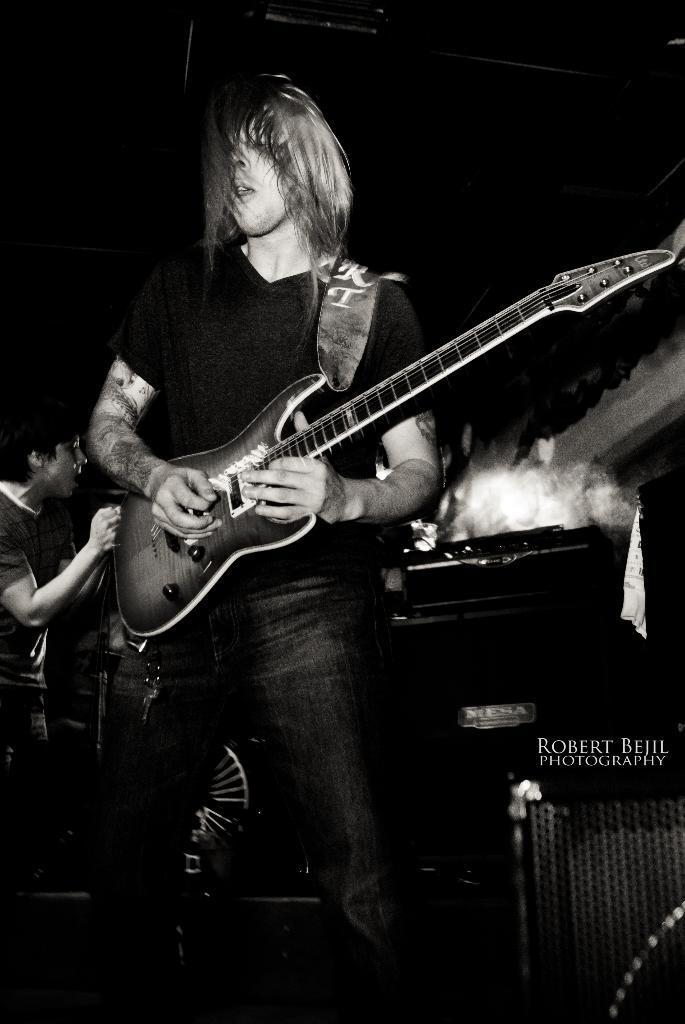How would you summarize this image in a sentence or two? In this image I can see a man is standing and I can see he is holding a guitar. In the background I can see one more person, a speaker and here I can see something is written. I can also see this image is black and white in colour. 